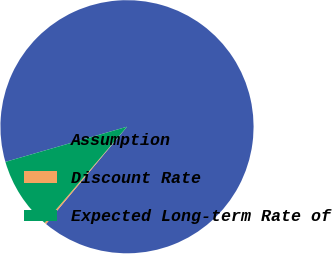Convert chart. <chart><loc_0><loc_0><loc_500><loc_500><pie_chart><fcel>Assumption<fcel>Discount Rate<fcel>Expected Long-term Rate of<nl><fcel>90.54%<fcel>0.22%<fcel>9.25%<nl></chart> 